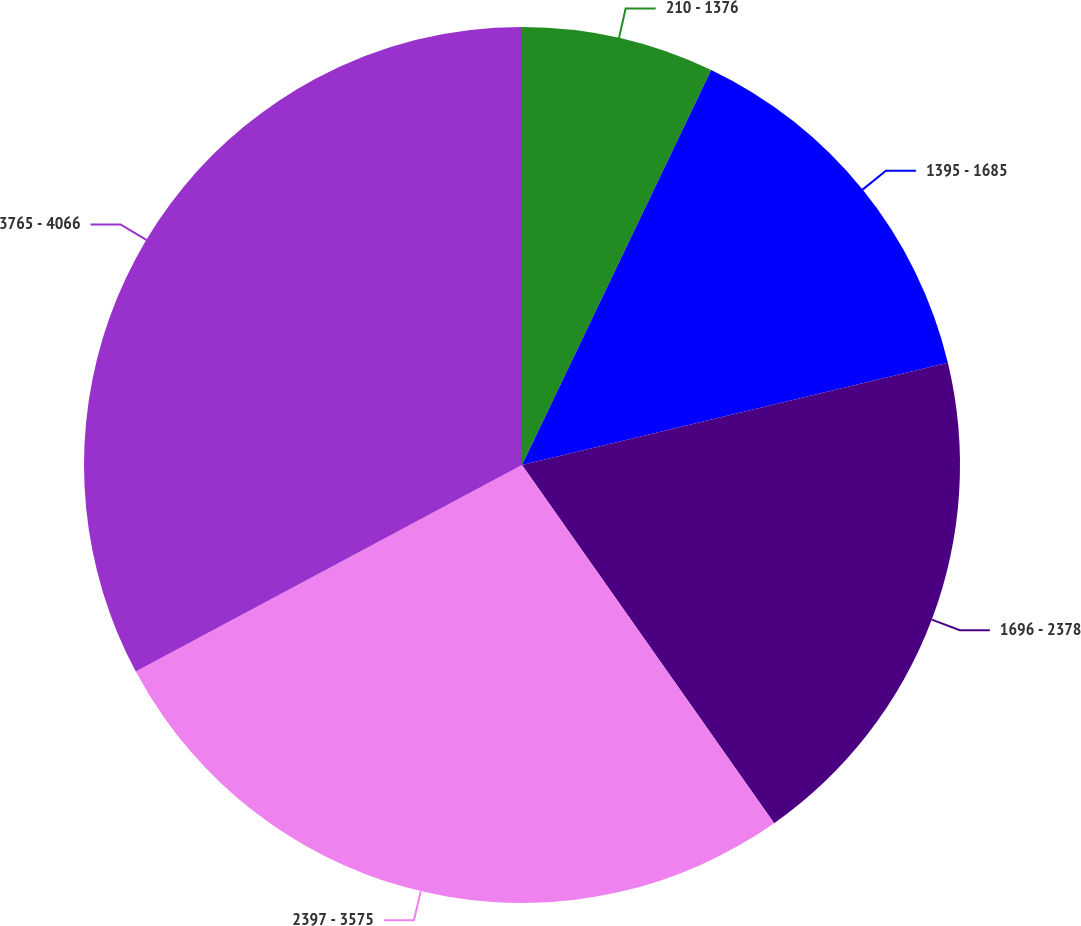Convert chart to OTSL. <chart><loc_0><loc_0><loc_500><loc_500><pie_chart><fcel>210 - 1376<fcel>1395 - 1685<fcel>1696 - 2378<fcel>2397 - 3575<fcel>3765 - 4066<nl><fcel>7.11%<fcel>14.14%<fcel>18.99%<fcel>26.95%<fcel>32.82%<nl></chart> 